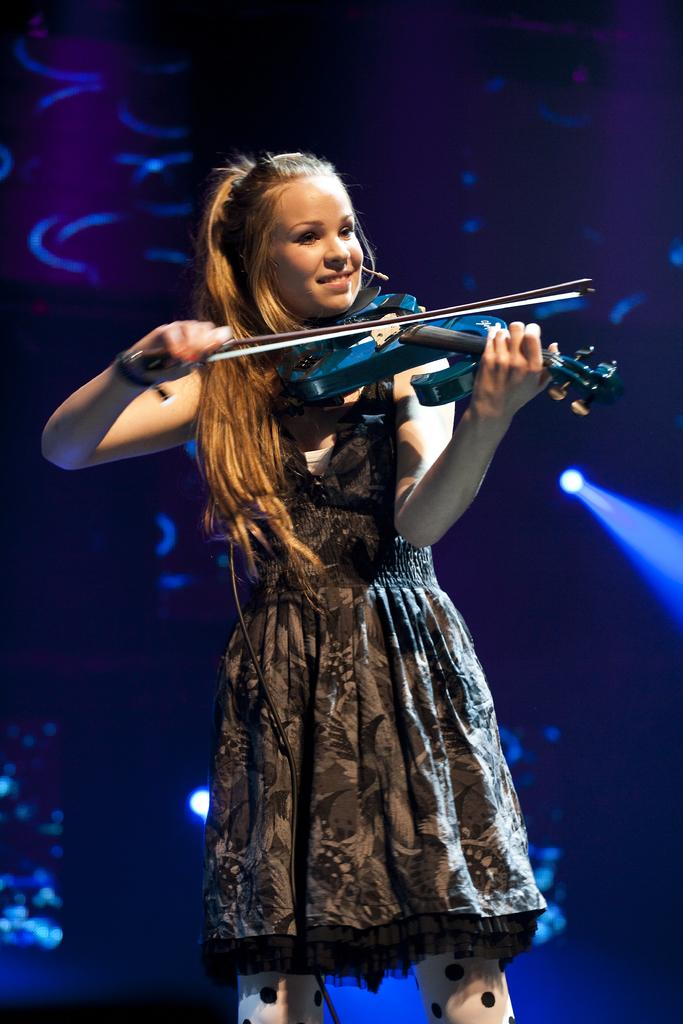What is the main subject of the image? The main subject of the image is a girl. What is the girl doing in the image? The girl is playing the violin. What type of poison is the girl using to play the violin in the image? There is no poison present in the image, and the girl is not using any poison to play the violin. What pets are visible in the image? There are no pets visible in the image; it features a girl playing the violin. 